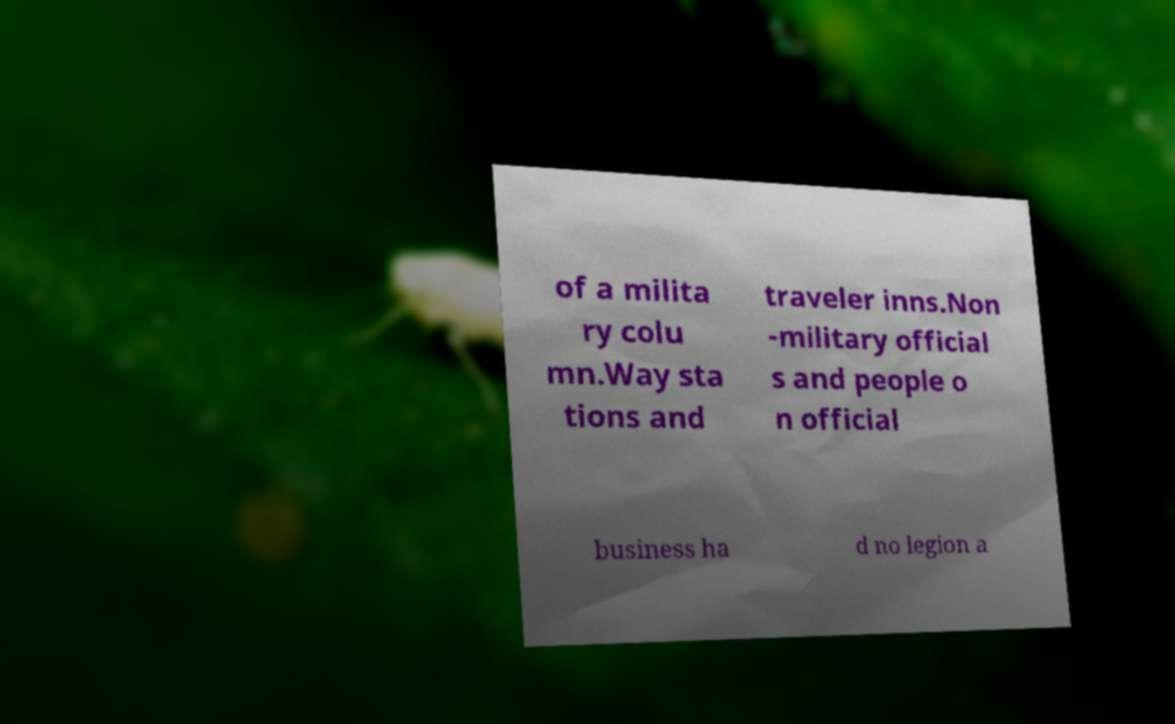Can you accurately transcribe the text from the provided image for me? of a milita ry colu mn.Way sta tions and traveler inns.Non -military official s and people o n official business ha d no legion a 